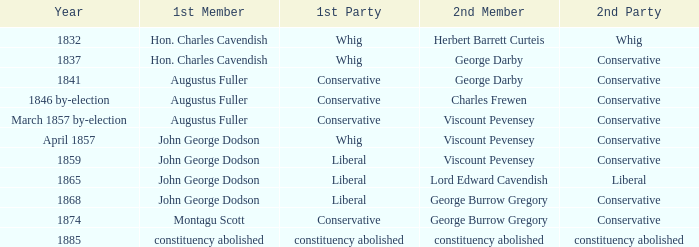Who, in 1837, was the second individual with the conservative party as their secondary affiliation? George Darby. 